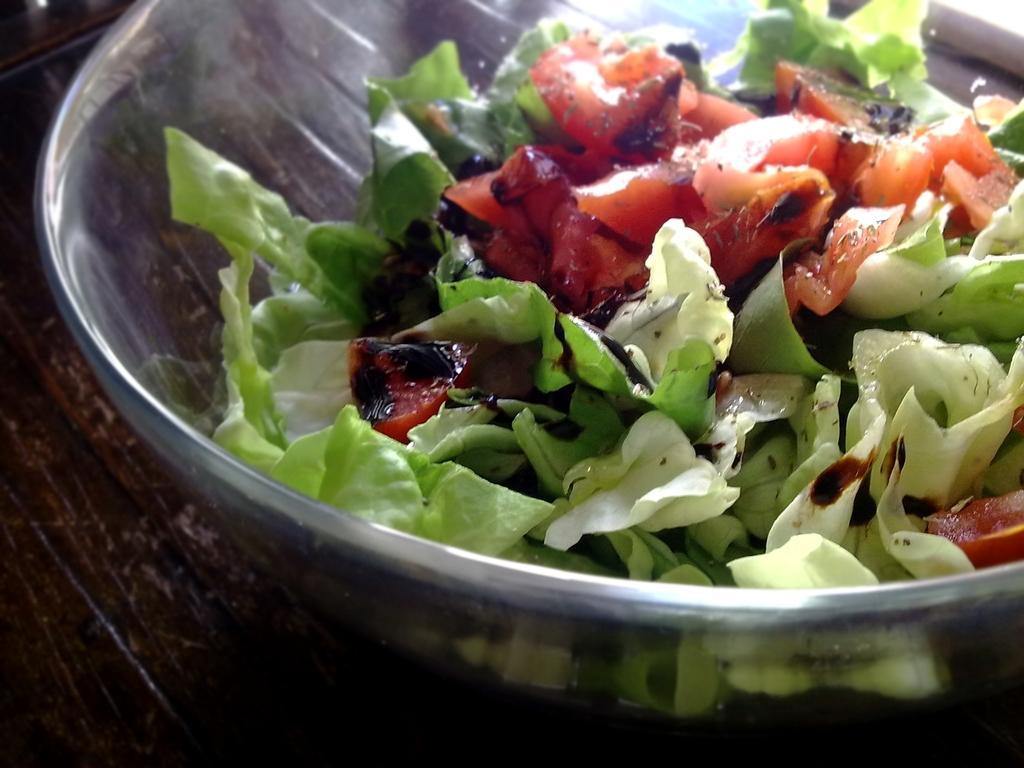Please provide a concise description of this image. In this image in the center there is one bowl and in the bowl there is salad, at the bottom there is table. 